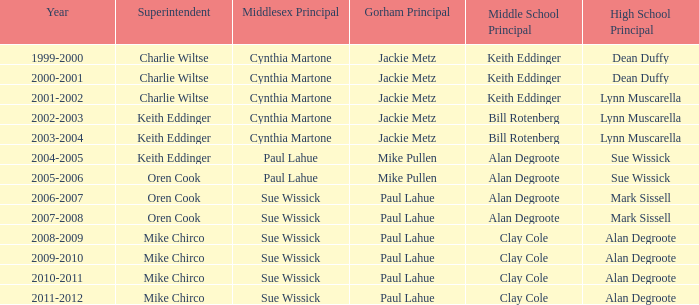How many years was lynn muscarella the high school principal and charlie wiltse the superintendent? 1.0. 